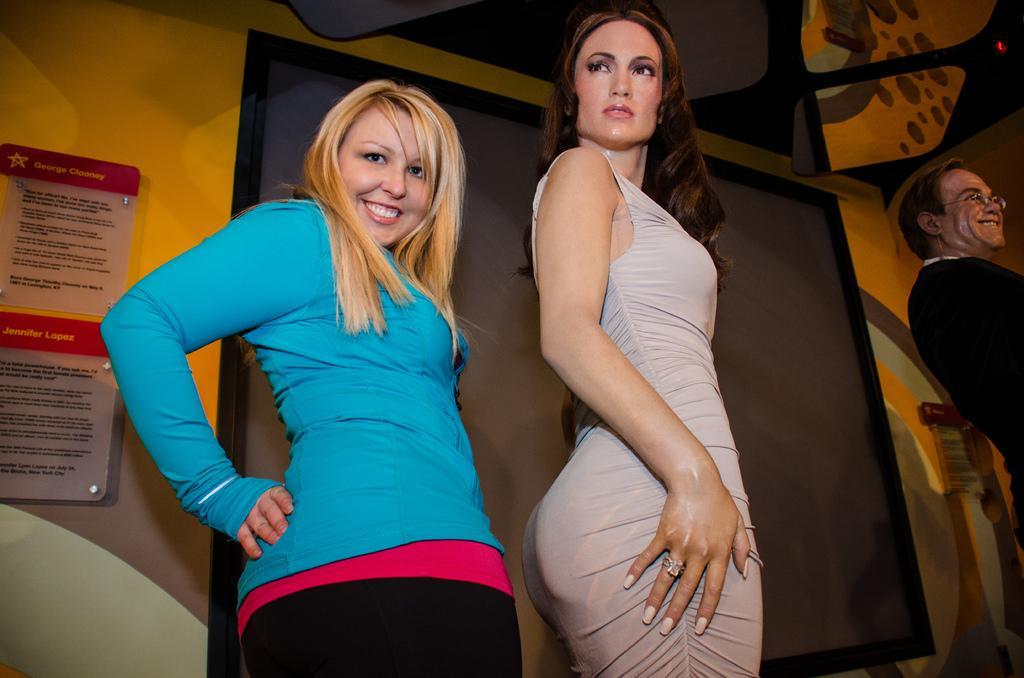Can you describe this image briefly? In this picture there is a woman who is wearing blue t-shirt and black trouser. She is a smiling, beside her there is a statue of a woman who is wearing grey dress and finger ring. On the right I can see the statue of a man who is wearing spectacles and suit. On the left there are posters behind the glass, beside that there is a black cloth. 